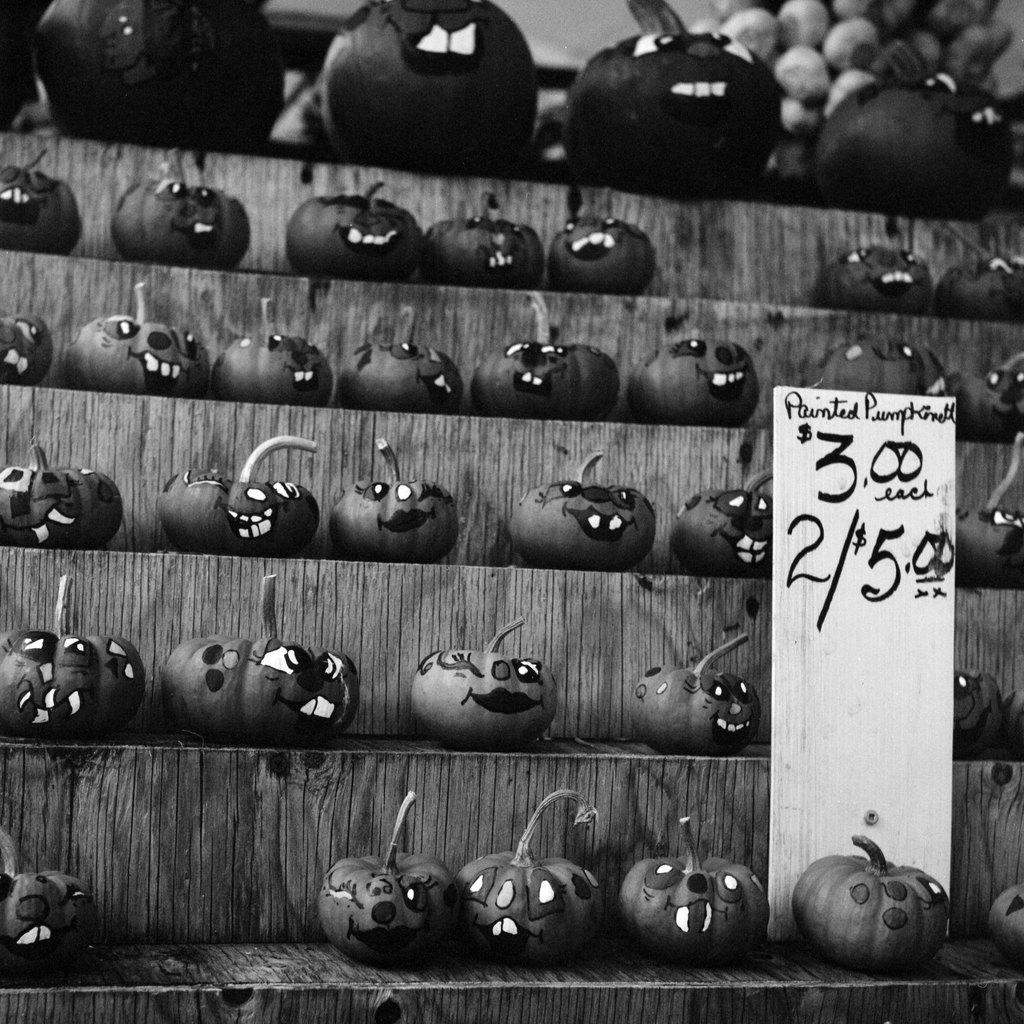What type of objects are featured in the image? There are painted pumpkins in the image. Where are the pumpkins located? The pumpkins are on an aisle. How can customers determine the price of the pumpkins? The pumpkins have price tags. What type of stem can be seen growing from the pumpkins in the image? There is no stem visible in the image, as the pumpkins are painted and likely not real. 